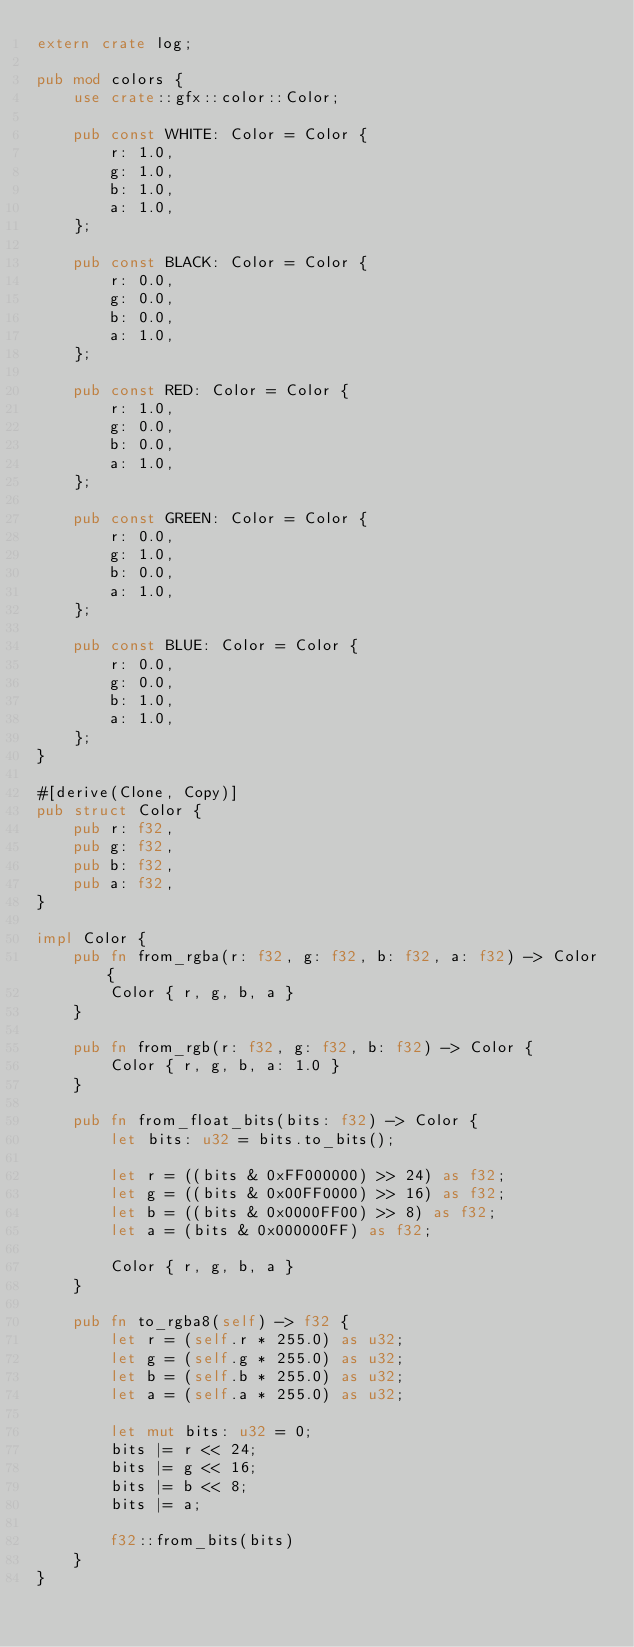Convert code to text. <code><loc_0><loc_0><loc_500><loc_500><_Rust_>extern crate log;

pub mod colors {
    use crate::gfx::color::Color;

    pub const WHITE: Color = Color {
        r: 1.0,
        g: 1.0,
        b: 1.0,
        a: 1.0,
    };

    pub const BLACK: Color = Color {
        r: 0.0,
        g: 0.0,
        b: 0.0,
        a: 1.0,
    };

    pub const RED: Color = Color {
        r: 1.0,
        g: 0.0,
        b: 0.0,
        a: 1.0,
    };

    pub const GREEN: Color = Color {
        r: 0.0,
        g: 1.0,
        b: 0.0,
        a: 1.0,
    };

    pub const BLUE: Color = Color {
        r: 0.0,
        g: 0.0,
        b: 1.0,
        a: 1.0,
    };
}

#[derive(Clone, Copy)]
pub struct Color {
    pub r: f32,
    pub g: f32,
    pub b: f32,
    pub a: f32,
}

impl Color {
    pub fn from_rgba(r: f32, g: f32, b: f32, a: f32) -> Color {
        Color { r, g, b, a }
    }

    pub fn from_rgb(r: f32, g: f32, b: f32) -> Color {
        Color { r, g, b, a: 1.0 }
    }

    pub fn from_float_bits(bits: f32) -> Color {
        let bits: u32 = bits.to_bits();

        let r = ((bits & 0xFF000000) >> 24) as f32;
        let g = ((bits & 0x00FF0000) >> 16) as f32;
        let b = ((bits & 0x0000FF00) >> 8) as f32;
        let a = (bits & 0x000000FF) as f32;

        Color { r, g, b, a }
    }

    pub fn to_rgba8(self) -> f32 {
        let r = (self.r * 255.0) as u32;
        let g = (self.g * 255.0) as u32;
        let b = (self.b * 255.0) as u32;
        let a = (self.a * 255.0) as u32;

        let mut bits: u32 = 0;
        bits |= r << 24;
        bits |= g << 16;
        bits |= b << 8;
        bits |= a;

        f32::from_bits(bits)
    }
}
</code> 